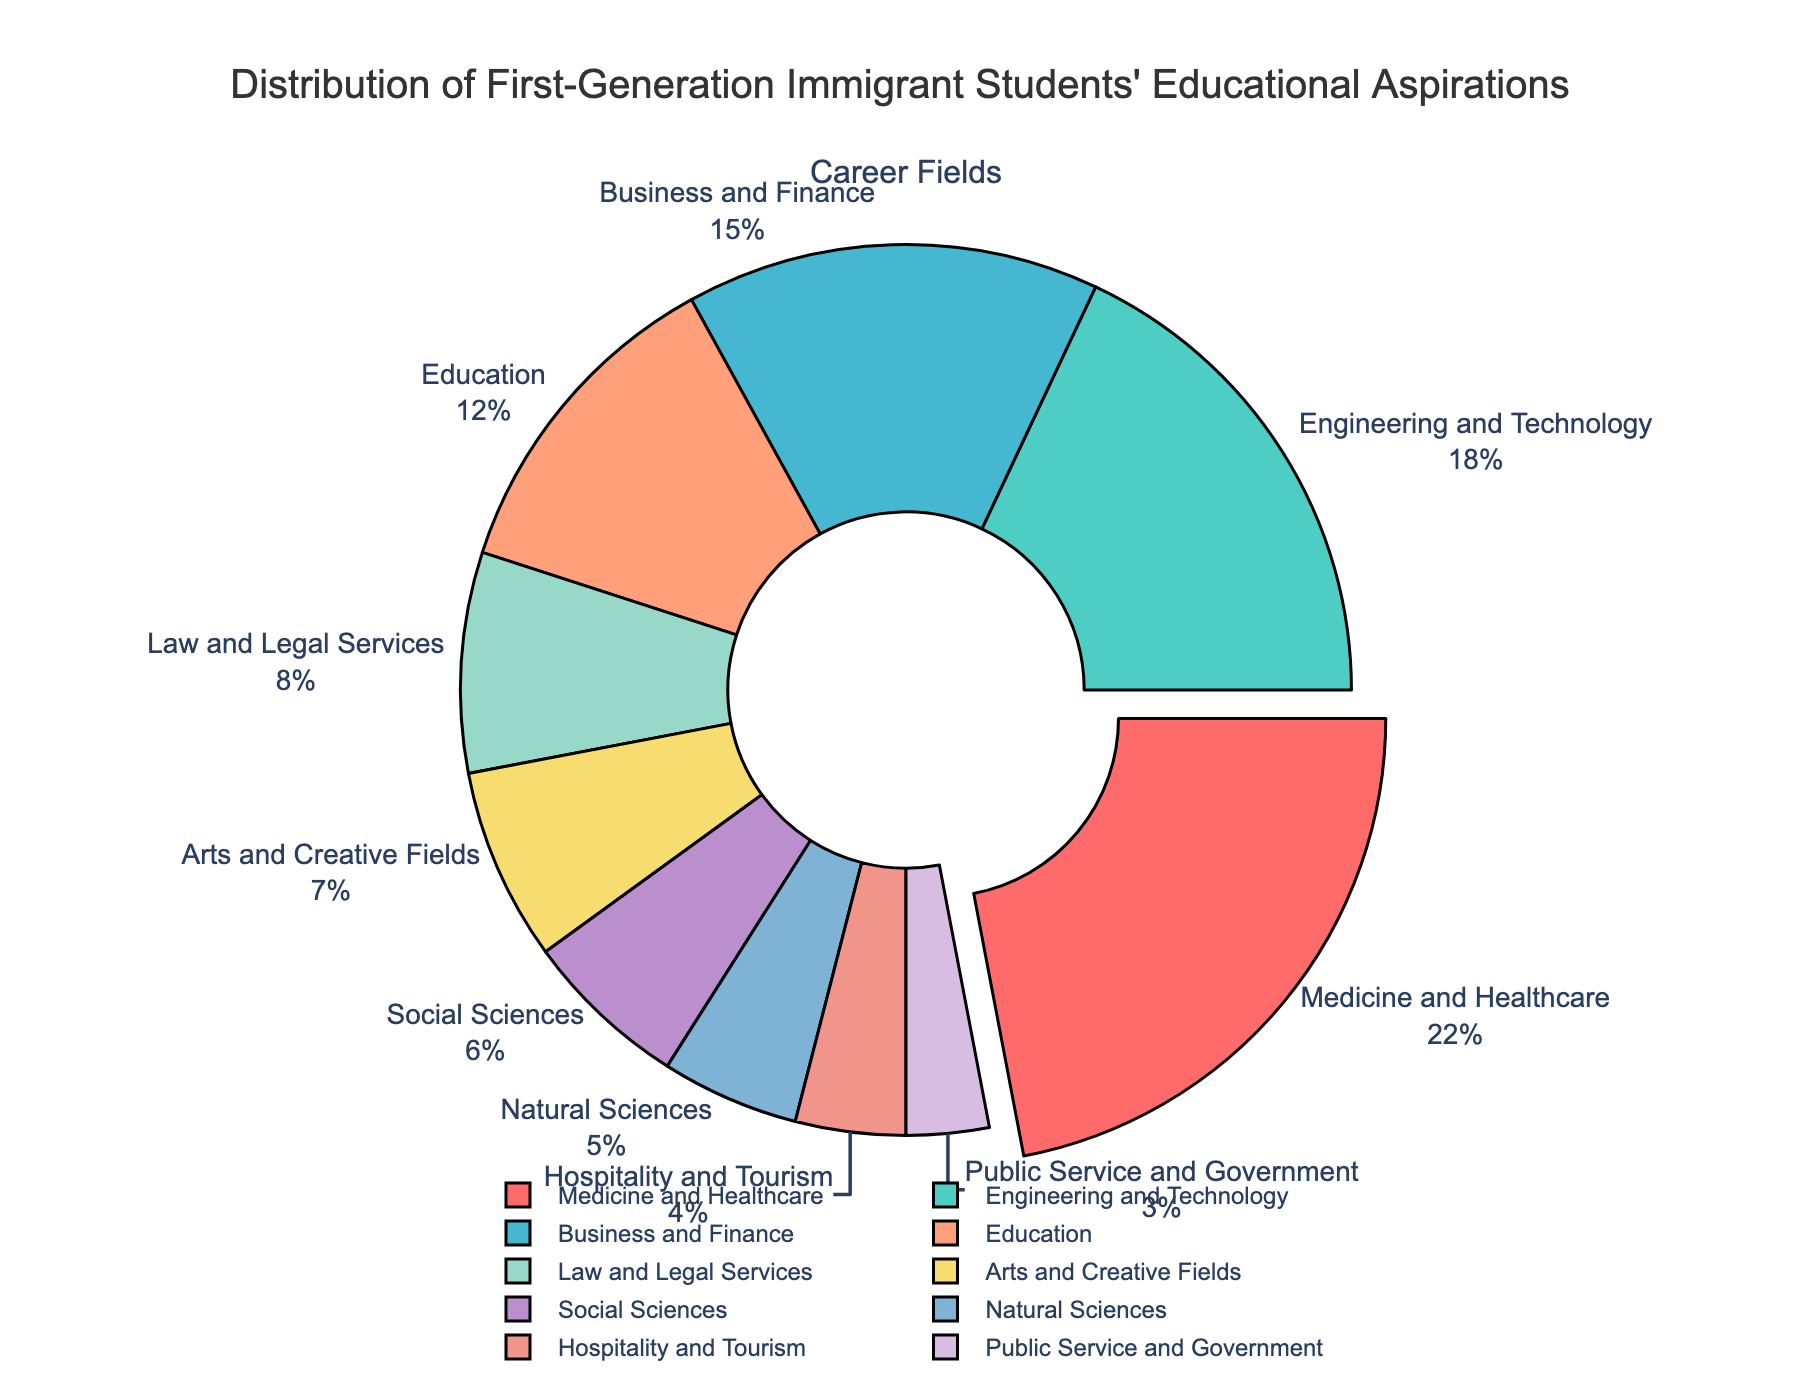What is the most popular career field among first-generation immigrant students? The largest section of the pie chart, which is slightly pulled out, represents the most popular career field. It is Medicine and Healthcare, which occupies 22% of the chart.
Answer: Medicine and Healthcare What is the combined percentage of students aspiring to a career in Engineering and Technology and Business and Finance? Add the percentage of students aspiring to a career in Engineering and Technology (18%) and Business and Finance (15%). 18% + 15% = 33%.
Answer: 33% Which career field has fewer students aspiring towards it, Public Service and Government or Natural Sciences? Compare the sizes of the slices in the pie chart for Public Service and Government (3%) and Natural Sciences (5%). The smaller slice represents Public Service and Government.
Answer: Public Service and Government How much more popular is Medicine and Healthcare compared to Law and Legal Services? Subtract the percentage of students aspiring to a career in Law and Legal Services (8%) from the percentage aspiring to Medicine and Healthcare (22%). 22% - 8% = 14%.
Answer: 14% What is the percentage of students aspiring to career fields in Arts and Creative Fields and Education combined? Sum the percentages of students aspiring to careers in Arts and Creative Fields (7%) and Education (12%). 7% + 12% = 19%.
Answer: 19% Compare the popularity of Hospitality and Tourism to Social Sciences. Which field has a higher percentage? Compare the percentages of Hospitality and Tourism (4%) and Social Sciences (6%). Social Sciences has a higher percentage.
Answer: Social Sciences What is the total percentage of students aspiring to careers in Natural Sciences, Public Service and Government, and Hospitality and Tourism combined? Add the percentages from Natural Sciences (5%), Public Service and Government (3%), and Hospitality and Tourism (4%). 5% + 3% + 4% = 12%.
Answer: 12% Which two fields are the least popular among first-generation immigrant students? Identify the two career fields with the smallest slices in the pie chart: Public Service and Government (3%) and Hospitality and Tourism (4%).
Answer: Public Service and Government, Hospitality and Tourism How does the percentage of students aspiring to a career in Law and Legal Services compare to that in Education? Compare the sizes of the slices labeled Law and Legal Services (8%) and Education (12%). The slice for Education is larger.
Answer: Education What would be the average percentage if we consider only Technology and Engineering fields from the pie chart? Only the field Engineering and Technology is included, which has a percentage of 18%. The average would be the value itself, as only one field is considered.
Answer: 18% 